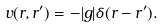<formula> <loc_0><loc_0><loc_500><loc_500>v ( { r } , { r ^ { \prime } } ) = - | g | \delta ( { r } - { r ^ { \prime } } ) .</formula> 